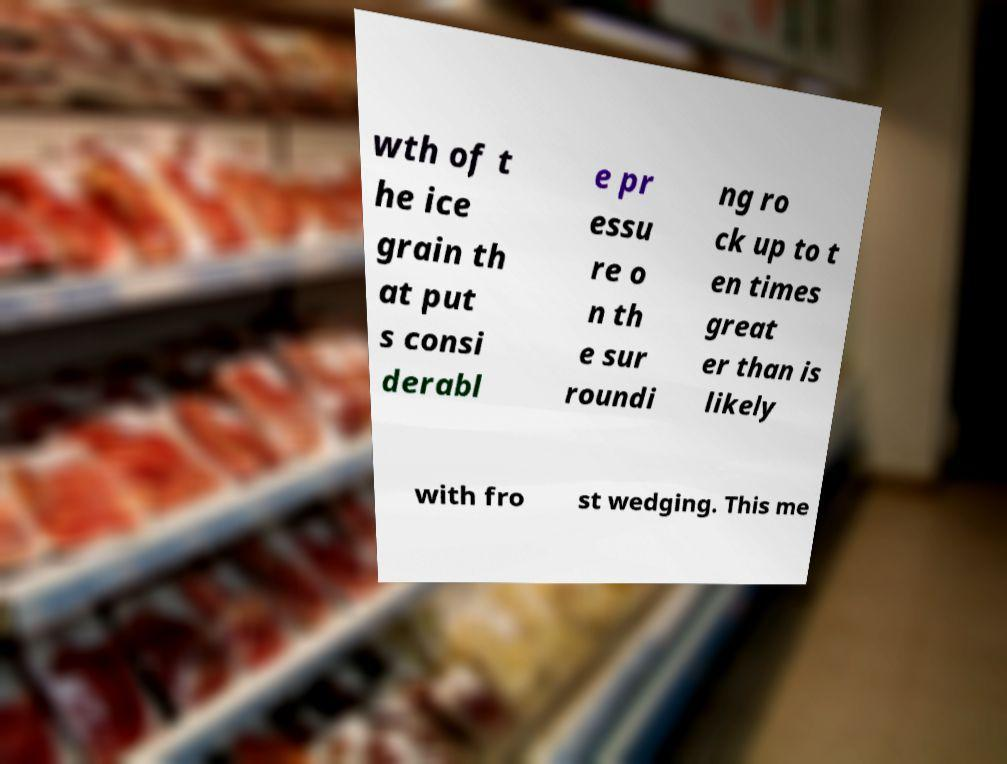Could you assist in decoding the text presented in this image and type it out clearly? wth of t he ice grain th at put s consi derabl e pr essu re o n th e sur roundi ng ro ck up to t en times great er than is likely with fro st wedging. This me 